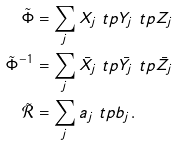Convert formula to latex. <formula><loc_0><loc_0><loc_500><loc_500>\tilde { \Phi } & = \sum _ { j } X _ { j } \ t p Y _ { j } \ t p Z _ { j } \\ { \tilde { \Phi } ^ { - 1 } } & = \sum _ { j } \bar { X _ { j } } \ t p \bar { Y _ { j } } \ t p \bar { Z _ { j } } \\ \tilde { \mathcal { R } } & = \sum _ { j } a _ { j } \ t p b _ { j } .</formula> 